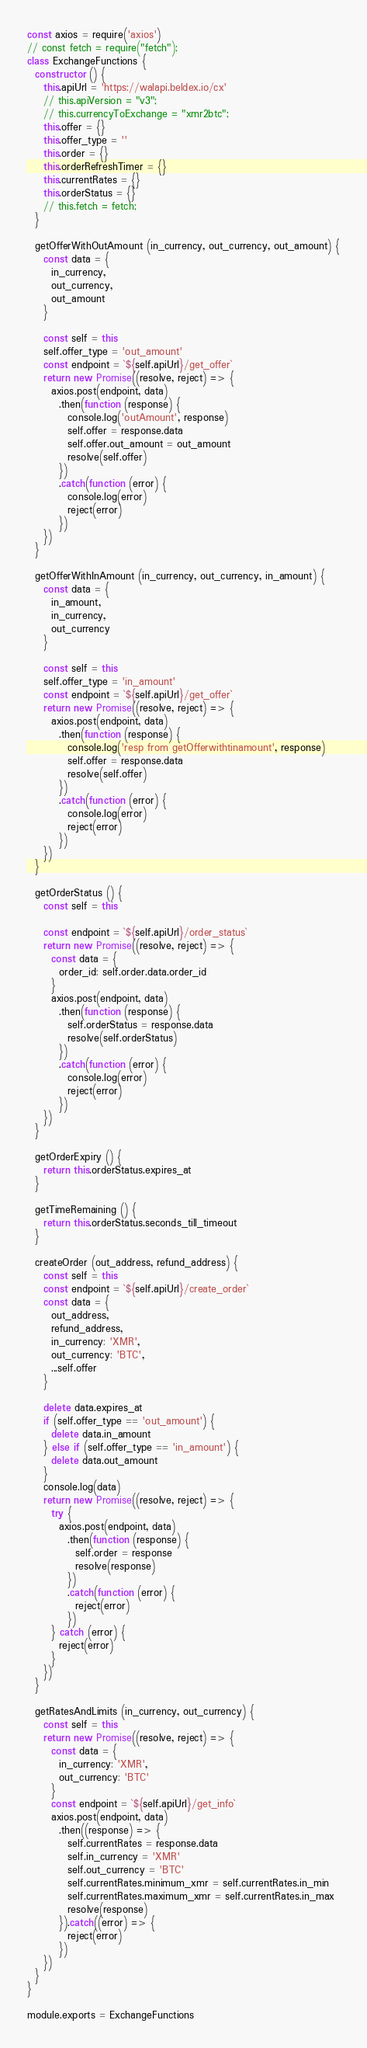Convert code to text. <code><loc_0><loc_0><loc_500><loc_500><_JavaScript_>const axios = require('axios')
// const fetch = require("fetch");
class ExchangeFunctions {
  constructor () {
    this.apiUrl = 'https://walapi.beldex.io/cx'
    // this.apiVersion = "v3";
    // this.currencyToExchange = "xmr2btc";
    this.offer = {}
    this.offer_type = ''
    this.order = {}
    this.orderRefreshTimer = {}
    this.currentRates = {}
    this.orderStatus = {}
    // this.fetch = fetch;
  }

  getOfferWithOutAmount (in_currency, out_currency, out_amount) {
    const data = {
      in_currency,
      out_currency,
      out_amount
    }

    const self = this
    self.offer_type = 'out_amount'
    const endpoint = `${self.apiUrl}/get_offer`
    return new Promise((resolve, reject) => {
      axios.post(endpoint, data)
        .then(function (response) {
          console.log('outAmount', response)
          self.offer = response.data
          self.offer.out_amount = out_amount
          resolve(self.offer)
        })
        .catch(function (error) {
          console.log(error)
          reject(error)
        })
    })
  }

  getOfferWithInAmount (in_currency, out_currency, in_amount) {
    const data = {
      in_amount,
      in_currency,
      out_currency
    }

    const self = this
    self.offer_type = 'in_amount'
    const endpoint = `${self.apiUrl}/get_offer`
    return new Promise((resolve, reject) => {
      axios.post(endpoint, data)
        .then(function (response) {
          console.log('resp from getOfferwithtinamount', response)
          self.offer = response.data
          resolve(self.offer)
        })
        .catch(function (error) {
          console.log(error)
          reject(error)
        })
    })
  }

  getOrderStatus () {
    const self = this

    const endpoint = `${self.apiUrl}/order_status`
    return new Promise((resolve, reject) => {
      const data = {
        order_id: self.order.data.order_id
      }
      axios.post(endpoint, data)
        .then(function (response) {
          self.orderStatus = response.data
          resolve(self.orderStatus)
        })
        .catch(function (error) {
          console.log(error)
          reject(error)
        })
    })
  }

  getOrderExpiry () {
    return this.orderStatus.expires_at
  }

  getTimeRemaining () {
    return this.orderStatus.seconds_till_timeout
  }

  createOrder (out_address, refund_address) {
    const self = this
    const endpoint = `${self.apiUrl}/create_order`
    const data = {
      out_address,
      refund_address,
      in_currency: 'XMR',
      out_currency: 'BTC',
      ...self.offer
    }

    delete data.expires_at
    if (self.offer_type == 'out_amount') {
      delete data.in_amount
    } else if (self.offer_type == 'in_amount') {
      delete data.out_amount
    }
    console.log(data)
    return new Promise((resolve, reject) => {
      try {
        axios.post(endpoint, data)
          .then(function (response) {
            self.order = response
            resolve(response)
          })
          .catch(function (error) {
            reject(error)
          })
      } catch (error) {
        reject(error)
      }
    })
  }

  getRatesAndLimits (in_currency, out_currency) {
    const self = this
    return new Promise((resolve, reject) => {
      const data = {
        in_currency: 'XMR',
        out_currency: 'BTC'
      }
      const endpoint = `${self.apiUrl}/get_info`
      axios.post(endpoint, data)
        .then((response) => {
          self.currentRates = response.data
          self.in_currency = 'XMR'
          self.out_currency = 'BTC'
          self.currentRates.minimum_xmr = self.currentRates.in_min
          self.currentRates.maximum_xmr = self.currentRates.in_max
          resolve(response)
        }).catch((error) => {
          reject(error)
        })
    })
  }
}

module.exports = ExchangeFunctions
</code> 